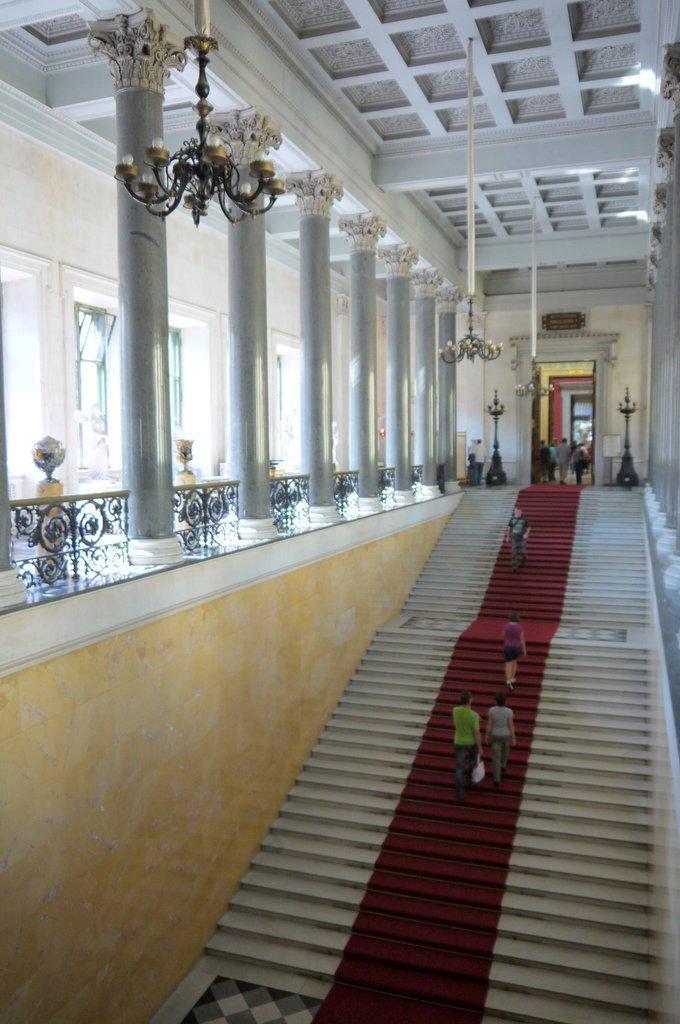Could you give a brief overview of what you see in this image? In this image, we can see some stairs and there are some people on the stairs, we can see some pillars and there is a fence. 